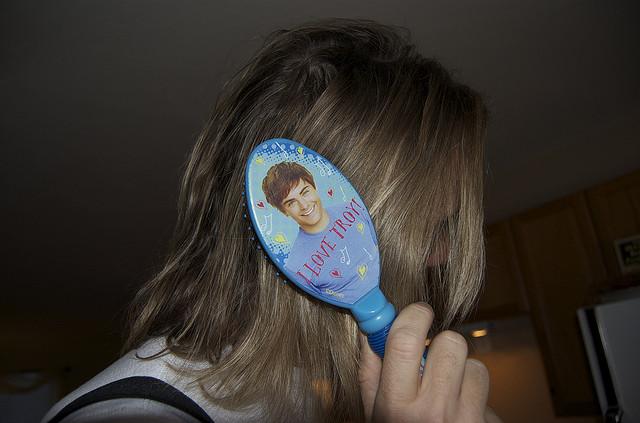Who is on the brush?
Short answer required. Zac efron. What color is the hairbrush?
Write a very short answer. Blue. What is on the brush?
Answer briefly. I love troy. What color is the brush?
Keep it brief. Blue. 